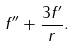Convert formula to latex. <formula><loc_0><loc_0><loc_500><loc_500>f ^ { \prime \prime } + \frac { 3 f ^ { \prime } } { r } .</formula> 